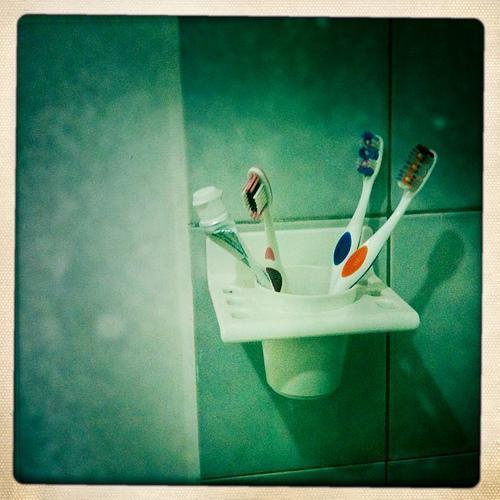How many toothbrushes are in the photo?
Give a very brief answer. 3. 